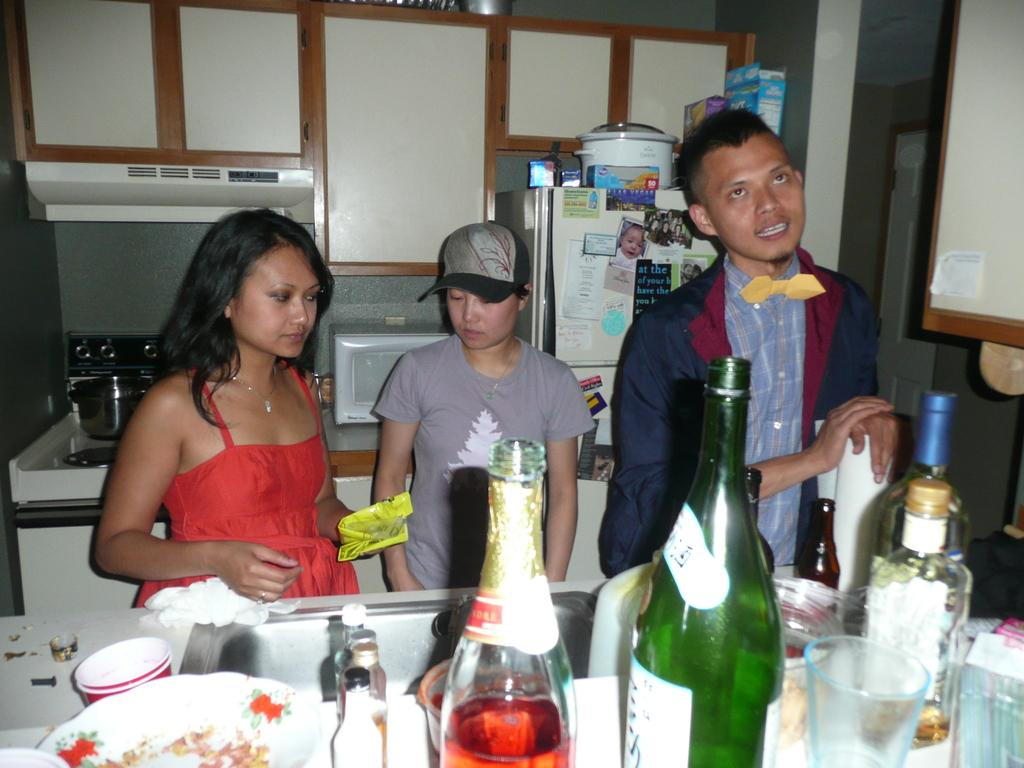How many people are in the image? There are three persons in the image. What are the persons doing in the image? The persons are standing in front of a wash basin. What is located in front of the wash basin? There is a table in front of the wash basin. What items can be seen on the table? The table has drink bottles and glasses on it. What can be seen in the background of the image? There is a refrigerator in the background of the image. What type of sack is being used to carry the business in the image? There is no sack or business present in the image; it features three persons standing in front of a wash basin with a table and a refrigerator in the background. 